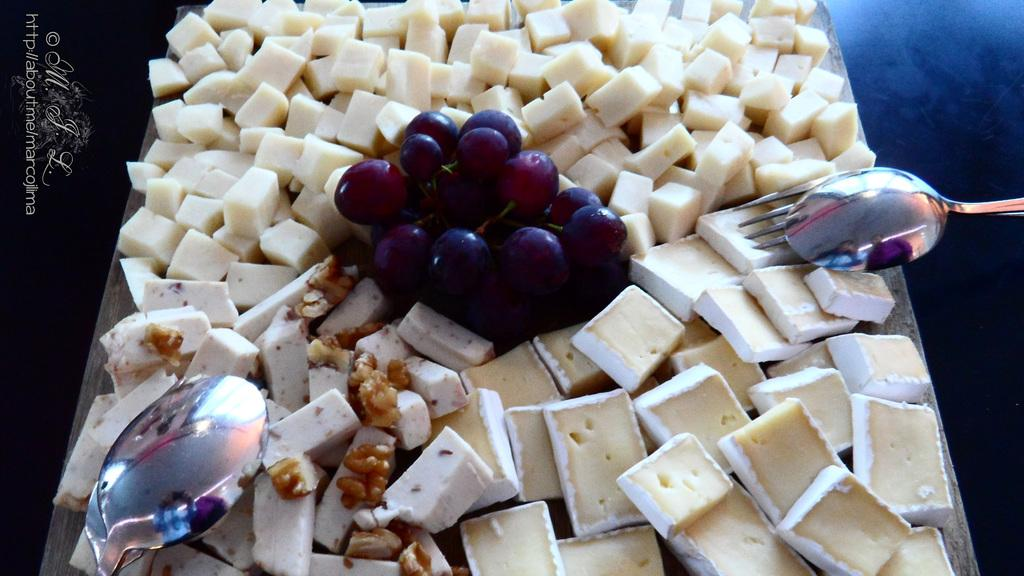What type of fruit can be seen in the image? There are grapes in the image. What else can be seen in the image besides the grapes? There are other food items and two spoons in the image. How are the food items arranged in the image? The items are placed on a tray. Where is the tray located in the image? The tray is placed on a table. Is there any text visible in the image? Yes, there is text on the left side of the image. Can you hear the song being sung by the zebra in the image? There is no zebra or song present in the image. 